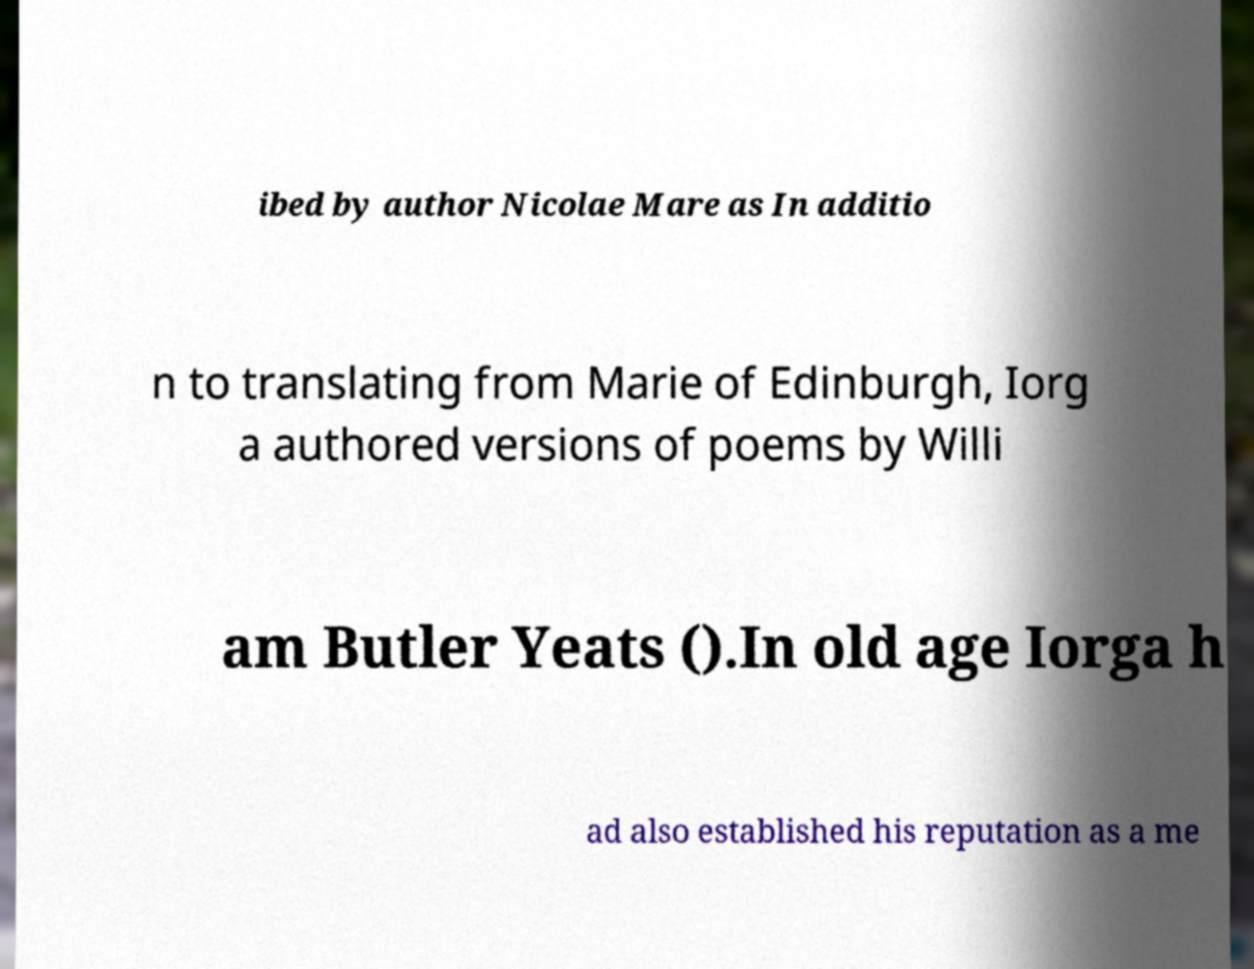Can you read and provide the text displayed in the image?This photo seems to have some interesting text. Can you extract and type it out for me? ibed by author Nicolae Mare as In additio n to translating from Marie of Edinburgh, Iorg a authored versions of poems by Willi am Butler Yeats ().In old age Iorga h ad also established his reputation as a me 